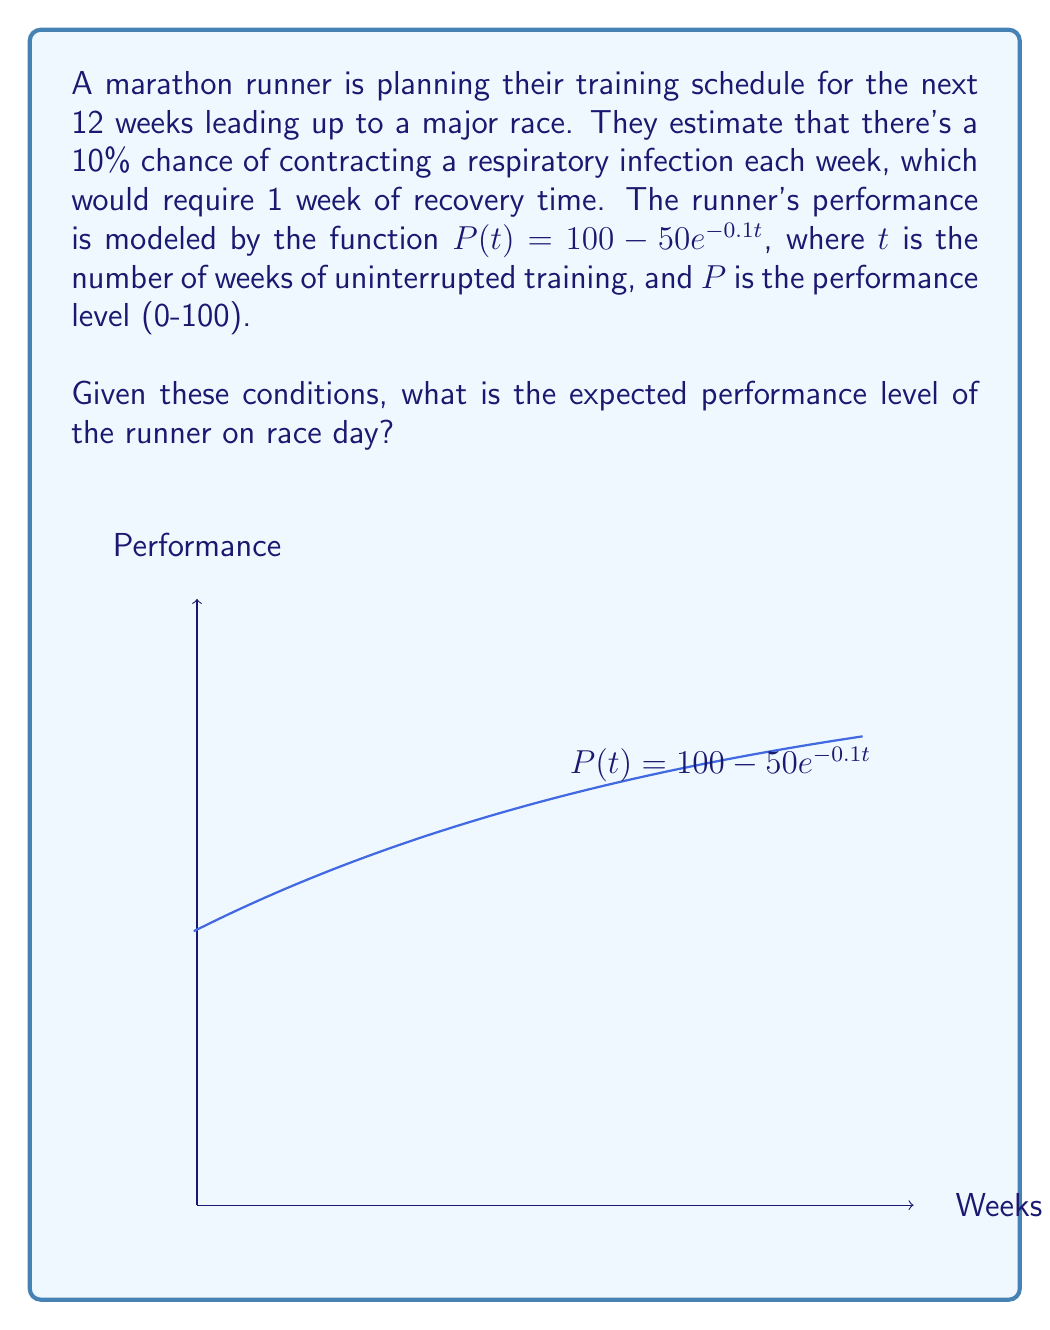Solve this math problem. Let's approach this step-by-step:

1) First, we need to calculate the probability of different training scenarios:

   a) Probability of no infections: $(0.9)^{12} \approx 0.2824$
   b) Probability of one infection: $12 \cdot 0.1 \cdot (0.9)^{11} \approx 0.3766$
   c) Probability of two infections: $\binom{12}{2} \cdot (0.1)^2 \cdot (0.9)^{10} \approx 0.2301$

2) For each scenario, we calculate the performance:

   a) No infections: $P(12) = 100 - 50e^{-0.1 \cdot 12} \approx 94.94$
   b) One infection: $P(11) = 100 - 50e^{-0.1 \cdot 11} \approx 93.94$
   c) Two infections: $P(10) = 100 - 50e^{-0.1 \cdot 10} \approx 92.76$

3) We can ignore scenarios with three or more infections as their probabilities are relatively small.

4) The expected performance is the sum of each performance multiplied by its probability:

   $E(P) = 94.94 \cdot 0.2824 + 93.94 \cdot 0.3766 + 92.76 \cdot 0.2301$

5) Calculating this:

   $E(P) = 26.81 + 35.38 + 21.34 = 83.53$

Therefore, the expected performance level on race day is approximately 83.53.
Answer: 83.53 